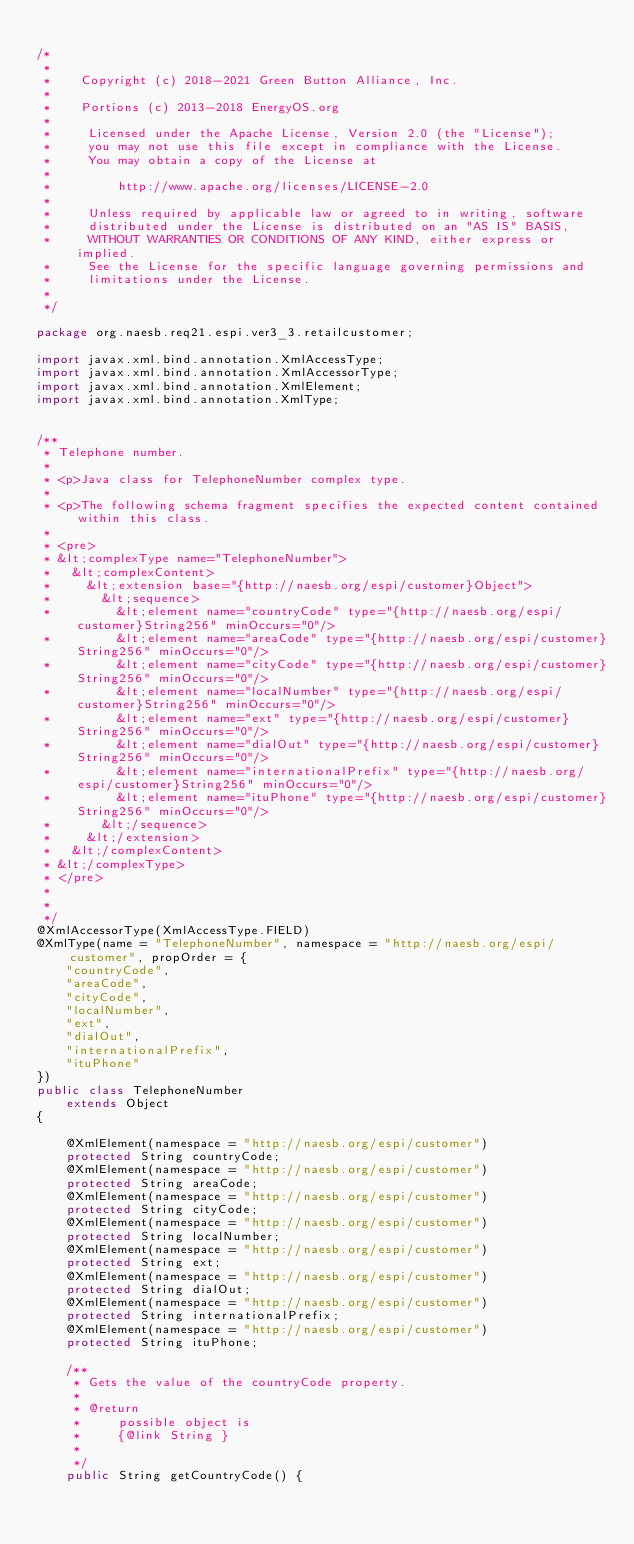Convert code to text. <code><loc_0><loc_0><loc_500><loc_500><_Java_>
/*
 *
 *    Copyright (c) 2018-2021 Green Button Alliance, Inc.
 *
 *    Portions (c) 2013-2018 EnergyOS.org
 *
 *     Licensed under the Apache License, Version 2.0 (the "License");
 *     you may not use this file except in compliance with the License.
 *     You may obtain a copy of the License at
 *
 *         http://www.apache.org/licenses/LICENSE-2.0
 *
 *     Unless required by applicable law or agreed to in writing, software
 *     distributed under the License is distributed on an "AS IS" BASIS,
 *     WITHOUT WARRANTIES OR CONDITIONS OF ANY KIND, either express or implied.
 *     See the License for the specific language governing permissions and
 *     limitations under the License.
 *
 */

package org.naesb.req21.espi.ver3_3.retailcustomer;

import javax.xml.bind.annotation.XmlAccessType;
import javax.xml.bind.annotation.XmlAccessorType;
import javax.xml.bind.annotation.XmlElement;
import javax.xml.bind.annotation.XmlType;


/**
 * Telephone number.
 * 
 * <p>Java class for TelephoneNumber complex type.
 * 
 * <p>The following schema fragment specifies the expected content contained within this class.
 * 
 * <pre>
 * &lt;complexType name="TelephoneNumber">
 *   &lt;complexContent>
 *     &lt;extension base="{http://naesb.org/espi/customer}Object">
 *       &lt;sequence>
 *         &lt;element name="countryCode" type="{http://naesb.org/espi/customer}String256" minOccurs="0"/>
 *         &lt;element name="areaCode" type="{http://naesb.org/espi/customer}String256" minOccurs="0"/>
 *         &lt;element name="cityCode" type="{http://naesb.org/espi/customer}String256" minOccurs="0"/>
 *         &lt;element name="localNumber" type="{http://naesb.org/espi/customer}String256" minOccurs="0"/>
 *         &lt;element name="ext" type="{http://naesb.org/espi/customer}String256" minOccurs="0"/>
 *         &lt;element name="dialOut" type="{http://naesb.org/espi/customer}String256" minOccurs="0"/>
 *         &lt;element name="internationalPrefix" type="{http://naesb.org/espi/customer}String256" minOccurs="0"/>
 *         &lt;element name="ituPhone" type="{http://naesb.org/espi/customer}String256" minOccurs="0"/>
 *       &lt;/sequence>
 *     &lt;/extension>
 *   &lt;/complexContent>
 * &lt;/complexType>
 * </pre>
 * 
 * 
 */
@XmlAccessorType(XmlAccessType.FIELD)
@XmlType(name = "TelephoneNumber", namespace = "http://naesb.org/espi/customer", propOrder = {
    "countryCode",
    "areaCode",
    "cityCode",
    "localNumber",
    "ext",
    "dialOut",
    "internationalPrefix",
    "ituPhone"
})
public class TelephoneNumber
    extends Object
{

    @XmlElement(namespace = "http://naesb.org/espi/customer")
    protected String countryCode;
    @XmlElement(namespace = "http://naesb.org/espi/customer")
    protected String areaCode;
    @XmlElement(namespace = "http://naesb.org/espi/customer")
    protected String cityCode;
    @XmlElement(namespace = "http://naesb.org/espi/customer")
    protected String localNumber;
    @XmlElement(namespace = "http://naesb.org/espi/customer")
    protected String ext;
    @XmlElement(namespace = "http://naesb.org/espi/customer")
    protected String dialOut;
    @XmlElement(namespace = "http://naesb.org/espi/customer")
    protected String internationalPrefix;
    @XmlElement(namespace = "http://naesb.org/espi/customer")
    protected String ituPhone;

    /**
     * Gets the value of the countryCode property.
     * 
     * @return
     *     possible object is
     *     {@link String }
     *     
     */
    public String getCountryCode() {</code> 